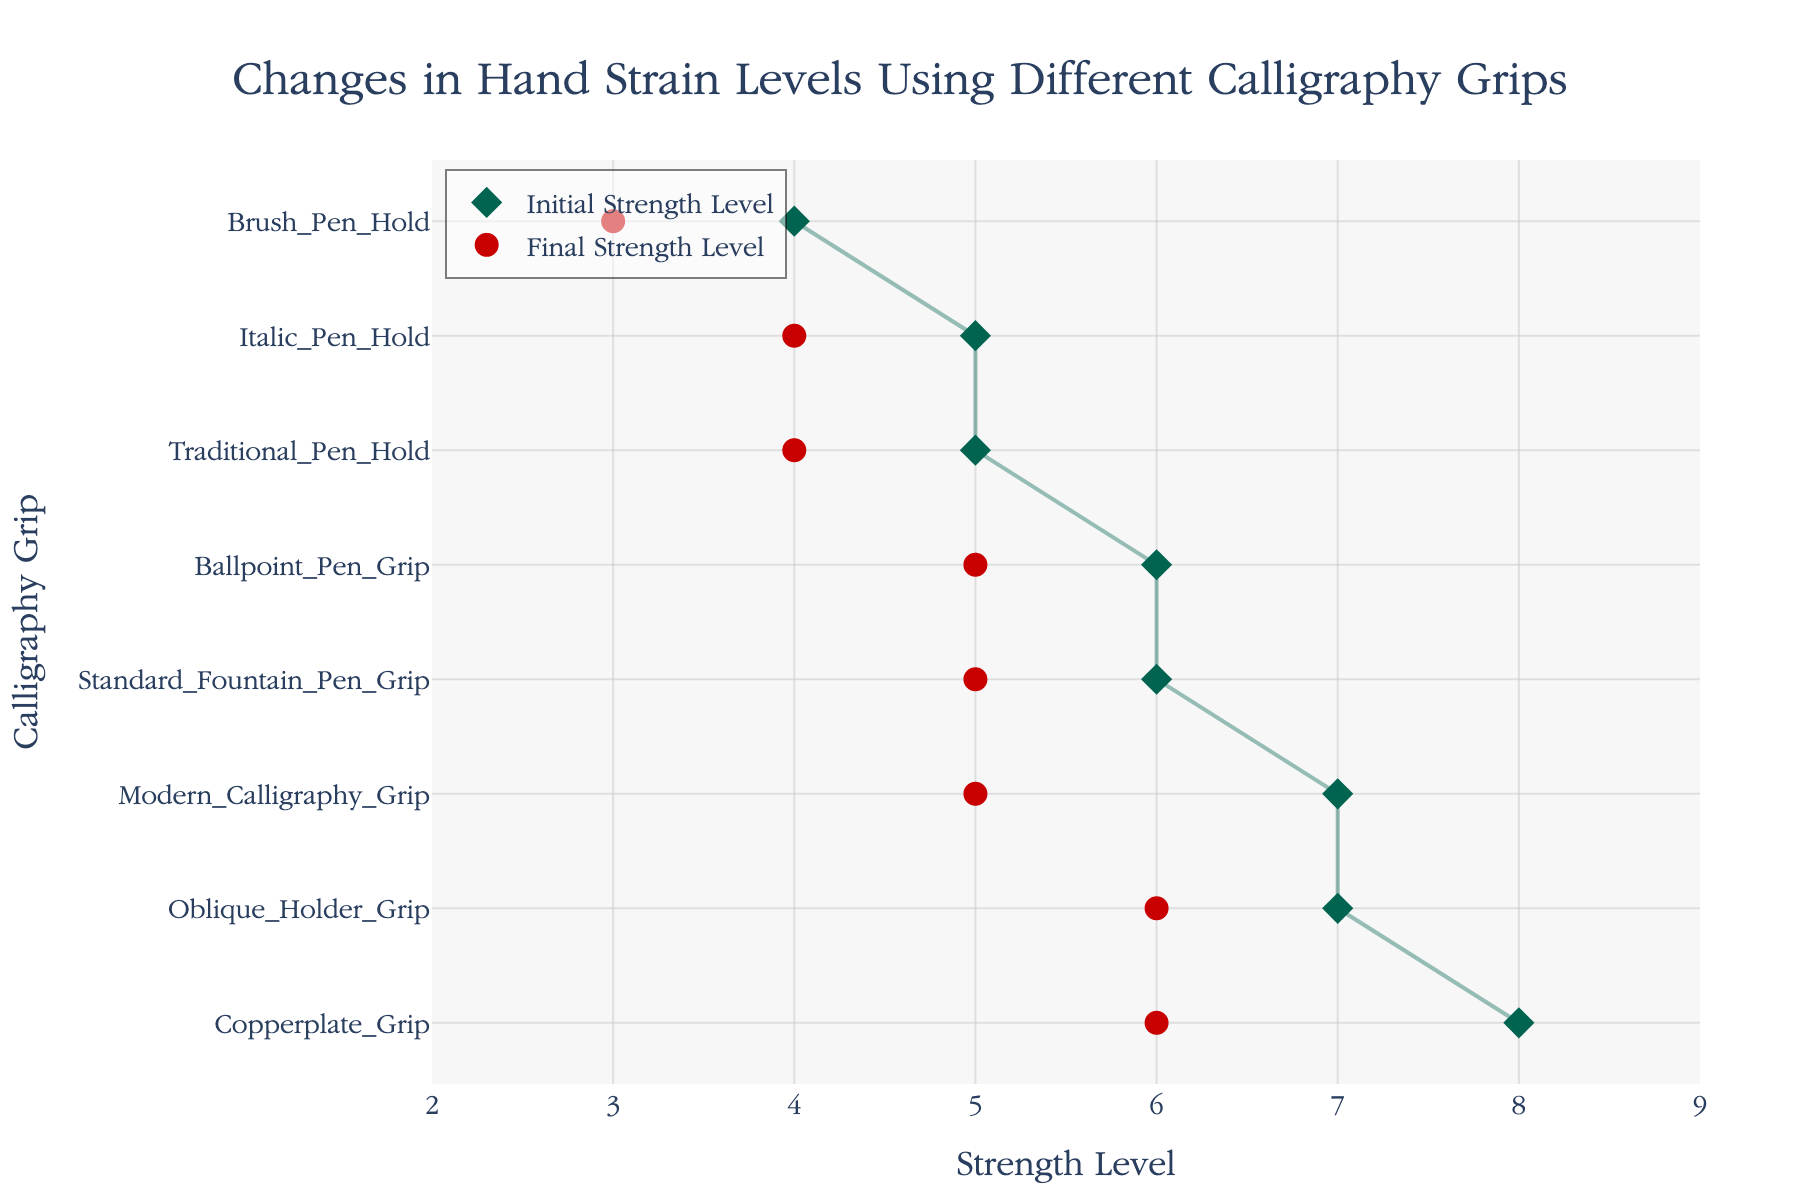What's the title of the figure? The title is usually located at the top of the figure and is designed to give an overall summary of what the figure is about, in this case, the title reads: "Changes in Hand Strain Levels Using Different Calligraphy Grips".
Answer: Changes in Hand Strain Levels Using Different Calligraphy Grips How many different calligraphy grips are shown in the figure? By counting the unique y-axis labels representing different calligraphy grips in the figure, we find there are eight.
Answer: Eight Which calligraphy grip has the highest initial strength level? Looking at the initial strength levels on the x-axis, the highest value is 8, which corresponds to the Copperplate Grip.
Answer: Copperplate Grip What is the difference in hand strain levels (initial vs final) for the Oblique Holder Grip? The initial strength level for the Oblique Holder Grip is 7 and the final strength level is 6. The difference is calculated as 7 - 6 = 1.
Answer: 1 How much did the hand strain level decrease for the Modern Calligraphy Grip? The initial strength level for the Modern Calligraphy Grip is 7 and the final strength level is 5. The decrease is calculated as 7 - 5 = 2.
Answer: 2 Which calligraphy grip had the largest decrease in hand strain level? By comparing the differences between initial and final strength levels for each grip, the largest decrease is from 8 to 6 for the Copperplate Grip, which is a decrease of 2.
Answer: Copperplate Grip What is the average final strength level across all grips? Adding up the final strength levels (4 + 5 + 3 + 6 + 5 + 4 + 6 + 5) gives 38. Dividing this sum by the number of grips (8) gives an average of 38 / 8 = 4.75.
Answer: 4.75 Are there any grips with no change in hand strain levels? By examining the initial and final strength levels for each grip, we see that all grips show a decrease, meaning no grip has a zero change.
Answer: No Which grips have an initial strength level of 5? By checking the initial strength levels against the corresponding grips, we find that Traditional Pen Hold and Italic Pen Hold both have an initial strength level of 5.
Answer: Traditional Pen Hold and Italic Pen Hold 